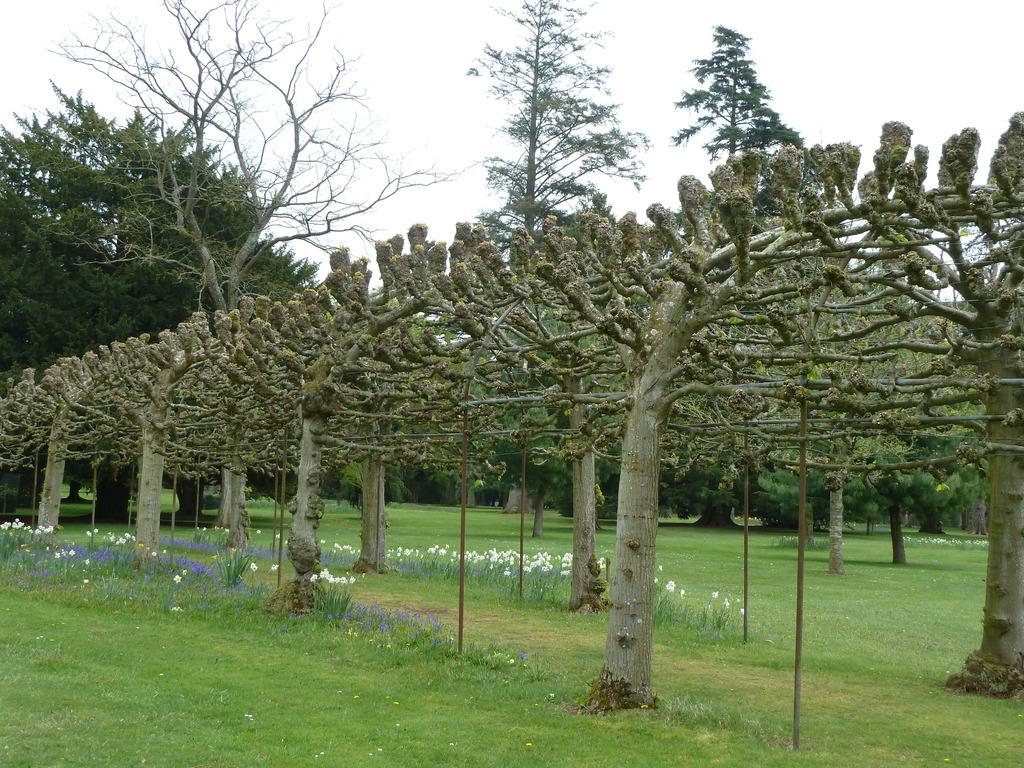What types of vegetation can be found in the garden? There are different types of plants in the garden, including trees and bushes with small flowers. Can you describe the trees in the garden? The facts provided do not give specific details about the trees in the garden. What kind of flowers are on the bushes? The flowers on the bushes are small. How many rings are visible on the cheese in the garden? There is no cheese present in the garden, and therefore no rings can be observed. 